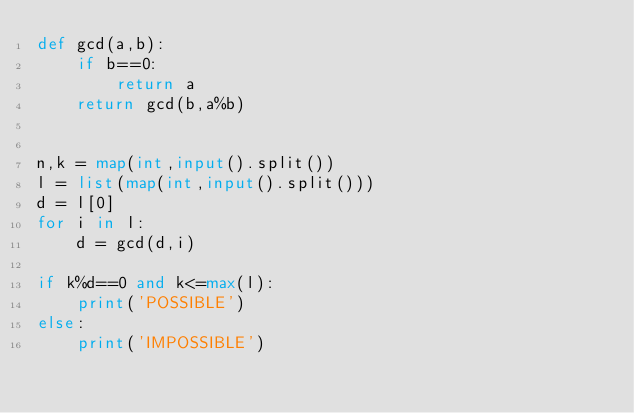<code> <loc_0><loc_0><loc_500><loc_500><_Python_>def gcd(a,b):
    if b==0:
        return a
    return gcd(b,a%b)


n,k = map(int,input().split())
l = list(map(int,input().split()))
d = l[0]
for i in l:
    d = gcd(d,i)

if k%d==0 and k<=max(l):
    print('POSSIBLE')
else:
    print('IMPOSSIBLE')</code> 